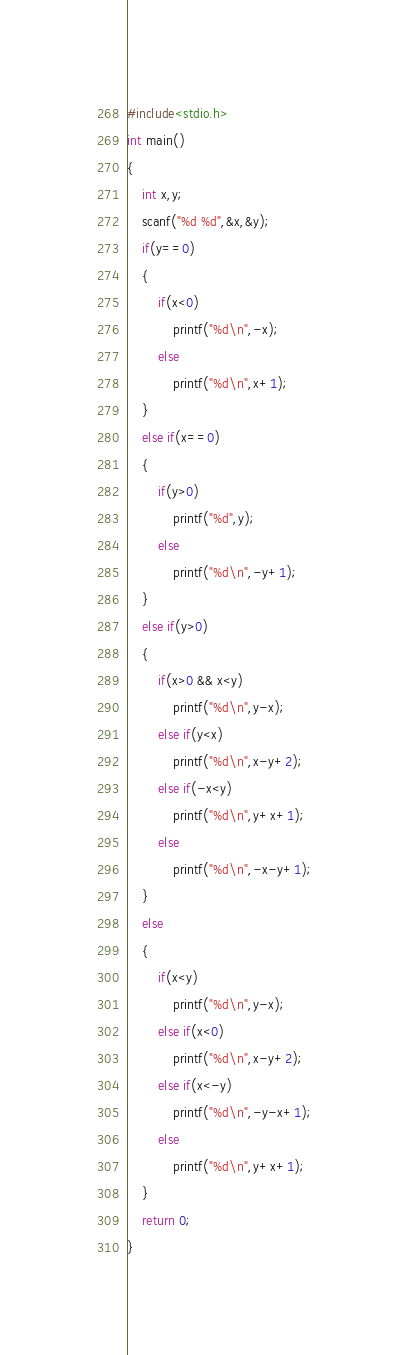<code> <loc_0><loc_0><loc_500><loc_500><_C_>#include<stdio.h>
int main()
{
	int x,y;
	scanf("%d %d",&x,&y);
	if(y==0)
	{
		if(x<0)
			printf("%d\n",-x);
		else
			printf("%d\n",x+1);
	}
	else if(x==0)
	{
		if(y>0)
			printf("%d",y);
		else
			printf("%d\n",-y+1);
	}
	else if(y>0)
	{
		if(x>0 && x<y)
			printf("%d\n",y-x);
		else if(y<x)
			printf("%d\n",x-y+2);
		else if(-x<y)
			printf("%d\n",y+x+1);
		else
			printf("%d\n",-x-y+1);
	}
	else
	{
		if(x<y)
			printf("%d\n",y-x);
		else if(x<0)
			printf("%d\n",x-y+2);
		else if(x<-y)
			printf("%d\n",-y-x+1);
		else
			printf("%d\n",y+x+1);
	}
	return 0;
}</code> 